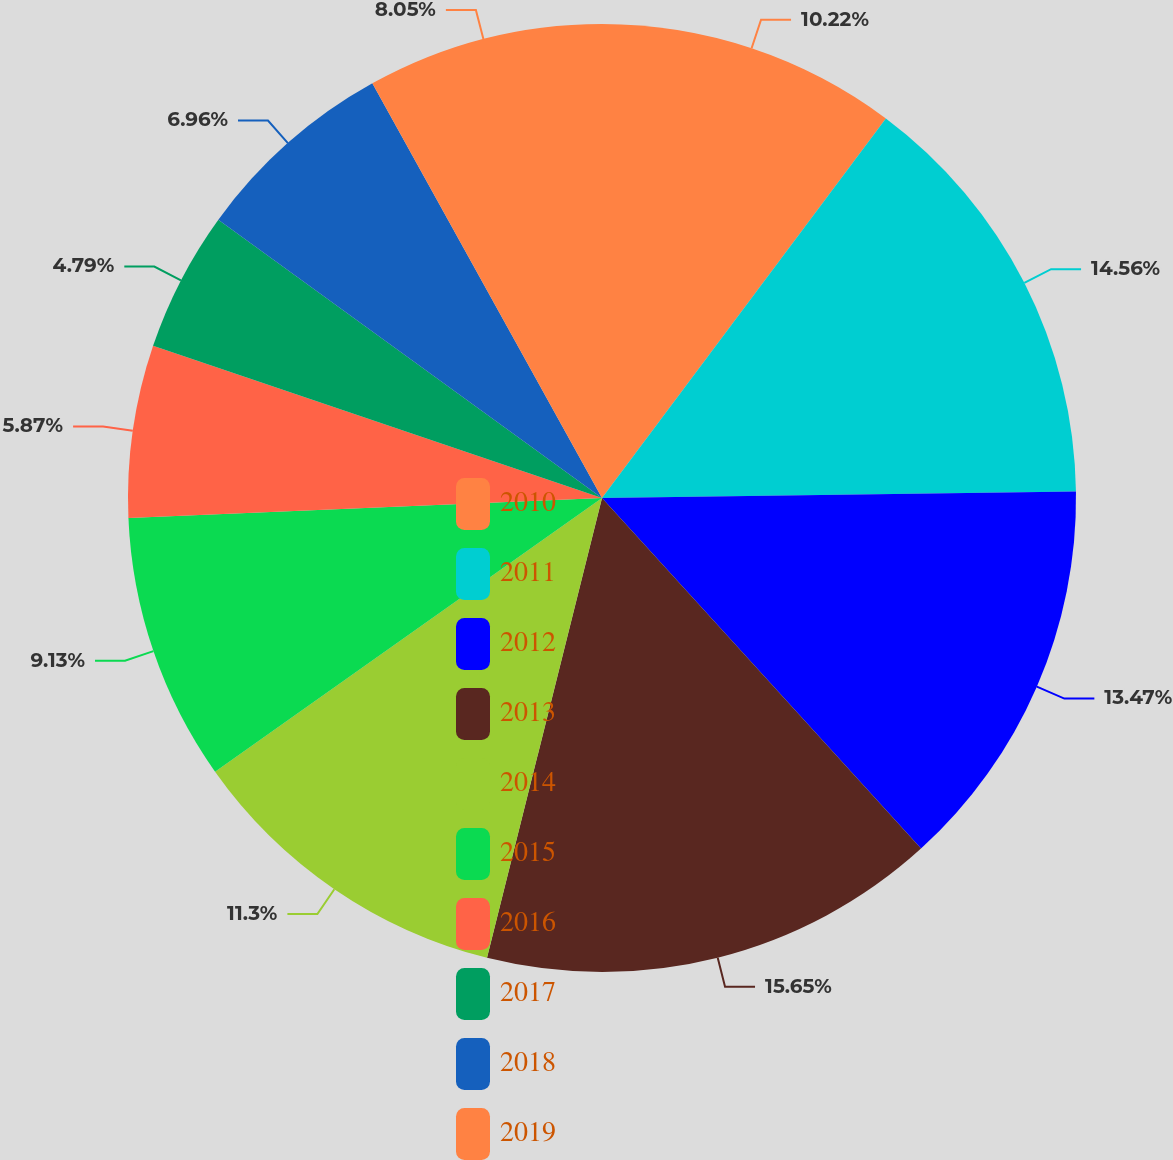<chart> <loc_0><loc_0><loc_500><loc_500><pie_chart><fcel>2010<fcel>2011<fcel>2012<fcel>2013<fcel>2014<fcel>2015<fcel>2016<fcel>2017<fcel>2018<fcel>2019<nl><fcel>10.22%<fcel>14.56%<fcel>13.47%<fcel>15.65%<fcel>11.3%<fcel>9.13%<fcel>5.87%<fcel>4.79%<fcel>6.96%<fcel>8.05%<nl></chart> 